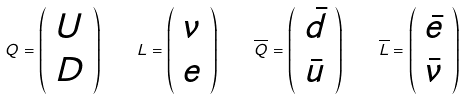Convert formula to latex. <formula><loc_0><loc_0><loc_500><loc_500>Q = \left ( { \begin{array} { c } U \\ D \end{array} } \right ) \quad L = \left ( { \begin{array} { c } \nu \\ e \end{array} } \right ) \quad \overline { Q } = \left ( { \begin{array} { c } { \bar { d } } \\ { \bar { u } } \end{array} } \right ) \quad \overline { L } = \left ( { \begin{array} { c } { \bar { e } } \\ { \bar { \nu } } \end{array} } \right )</formula> 